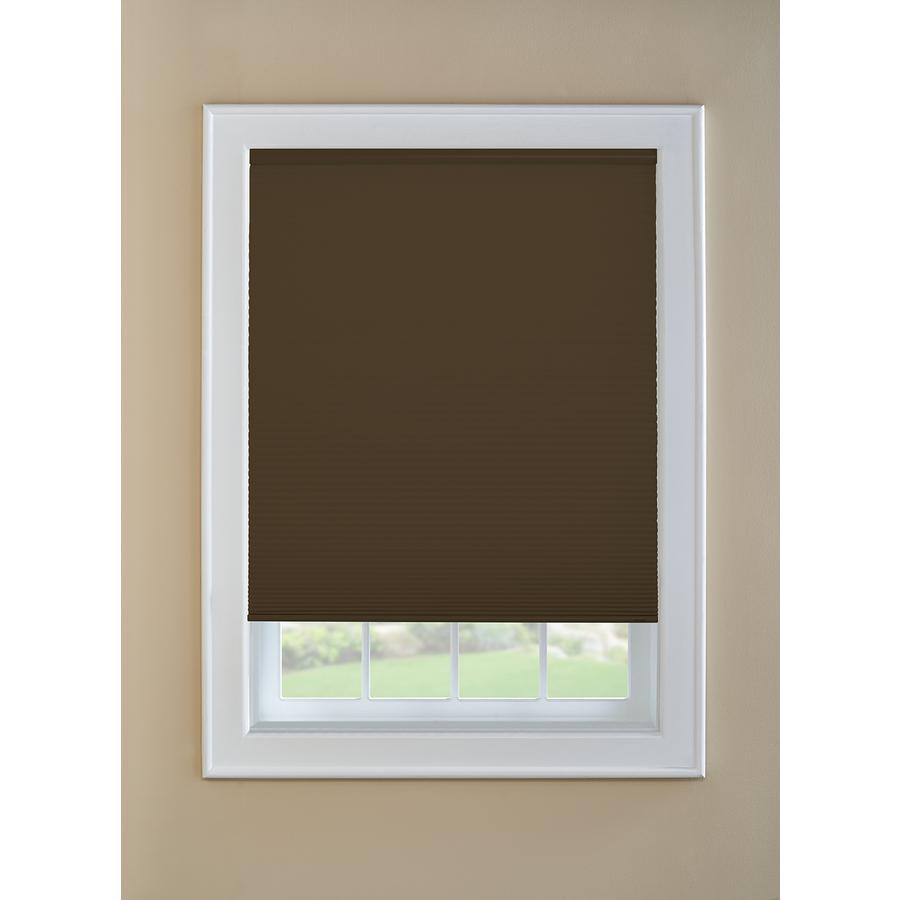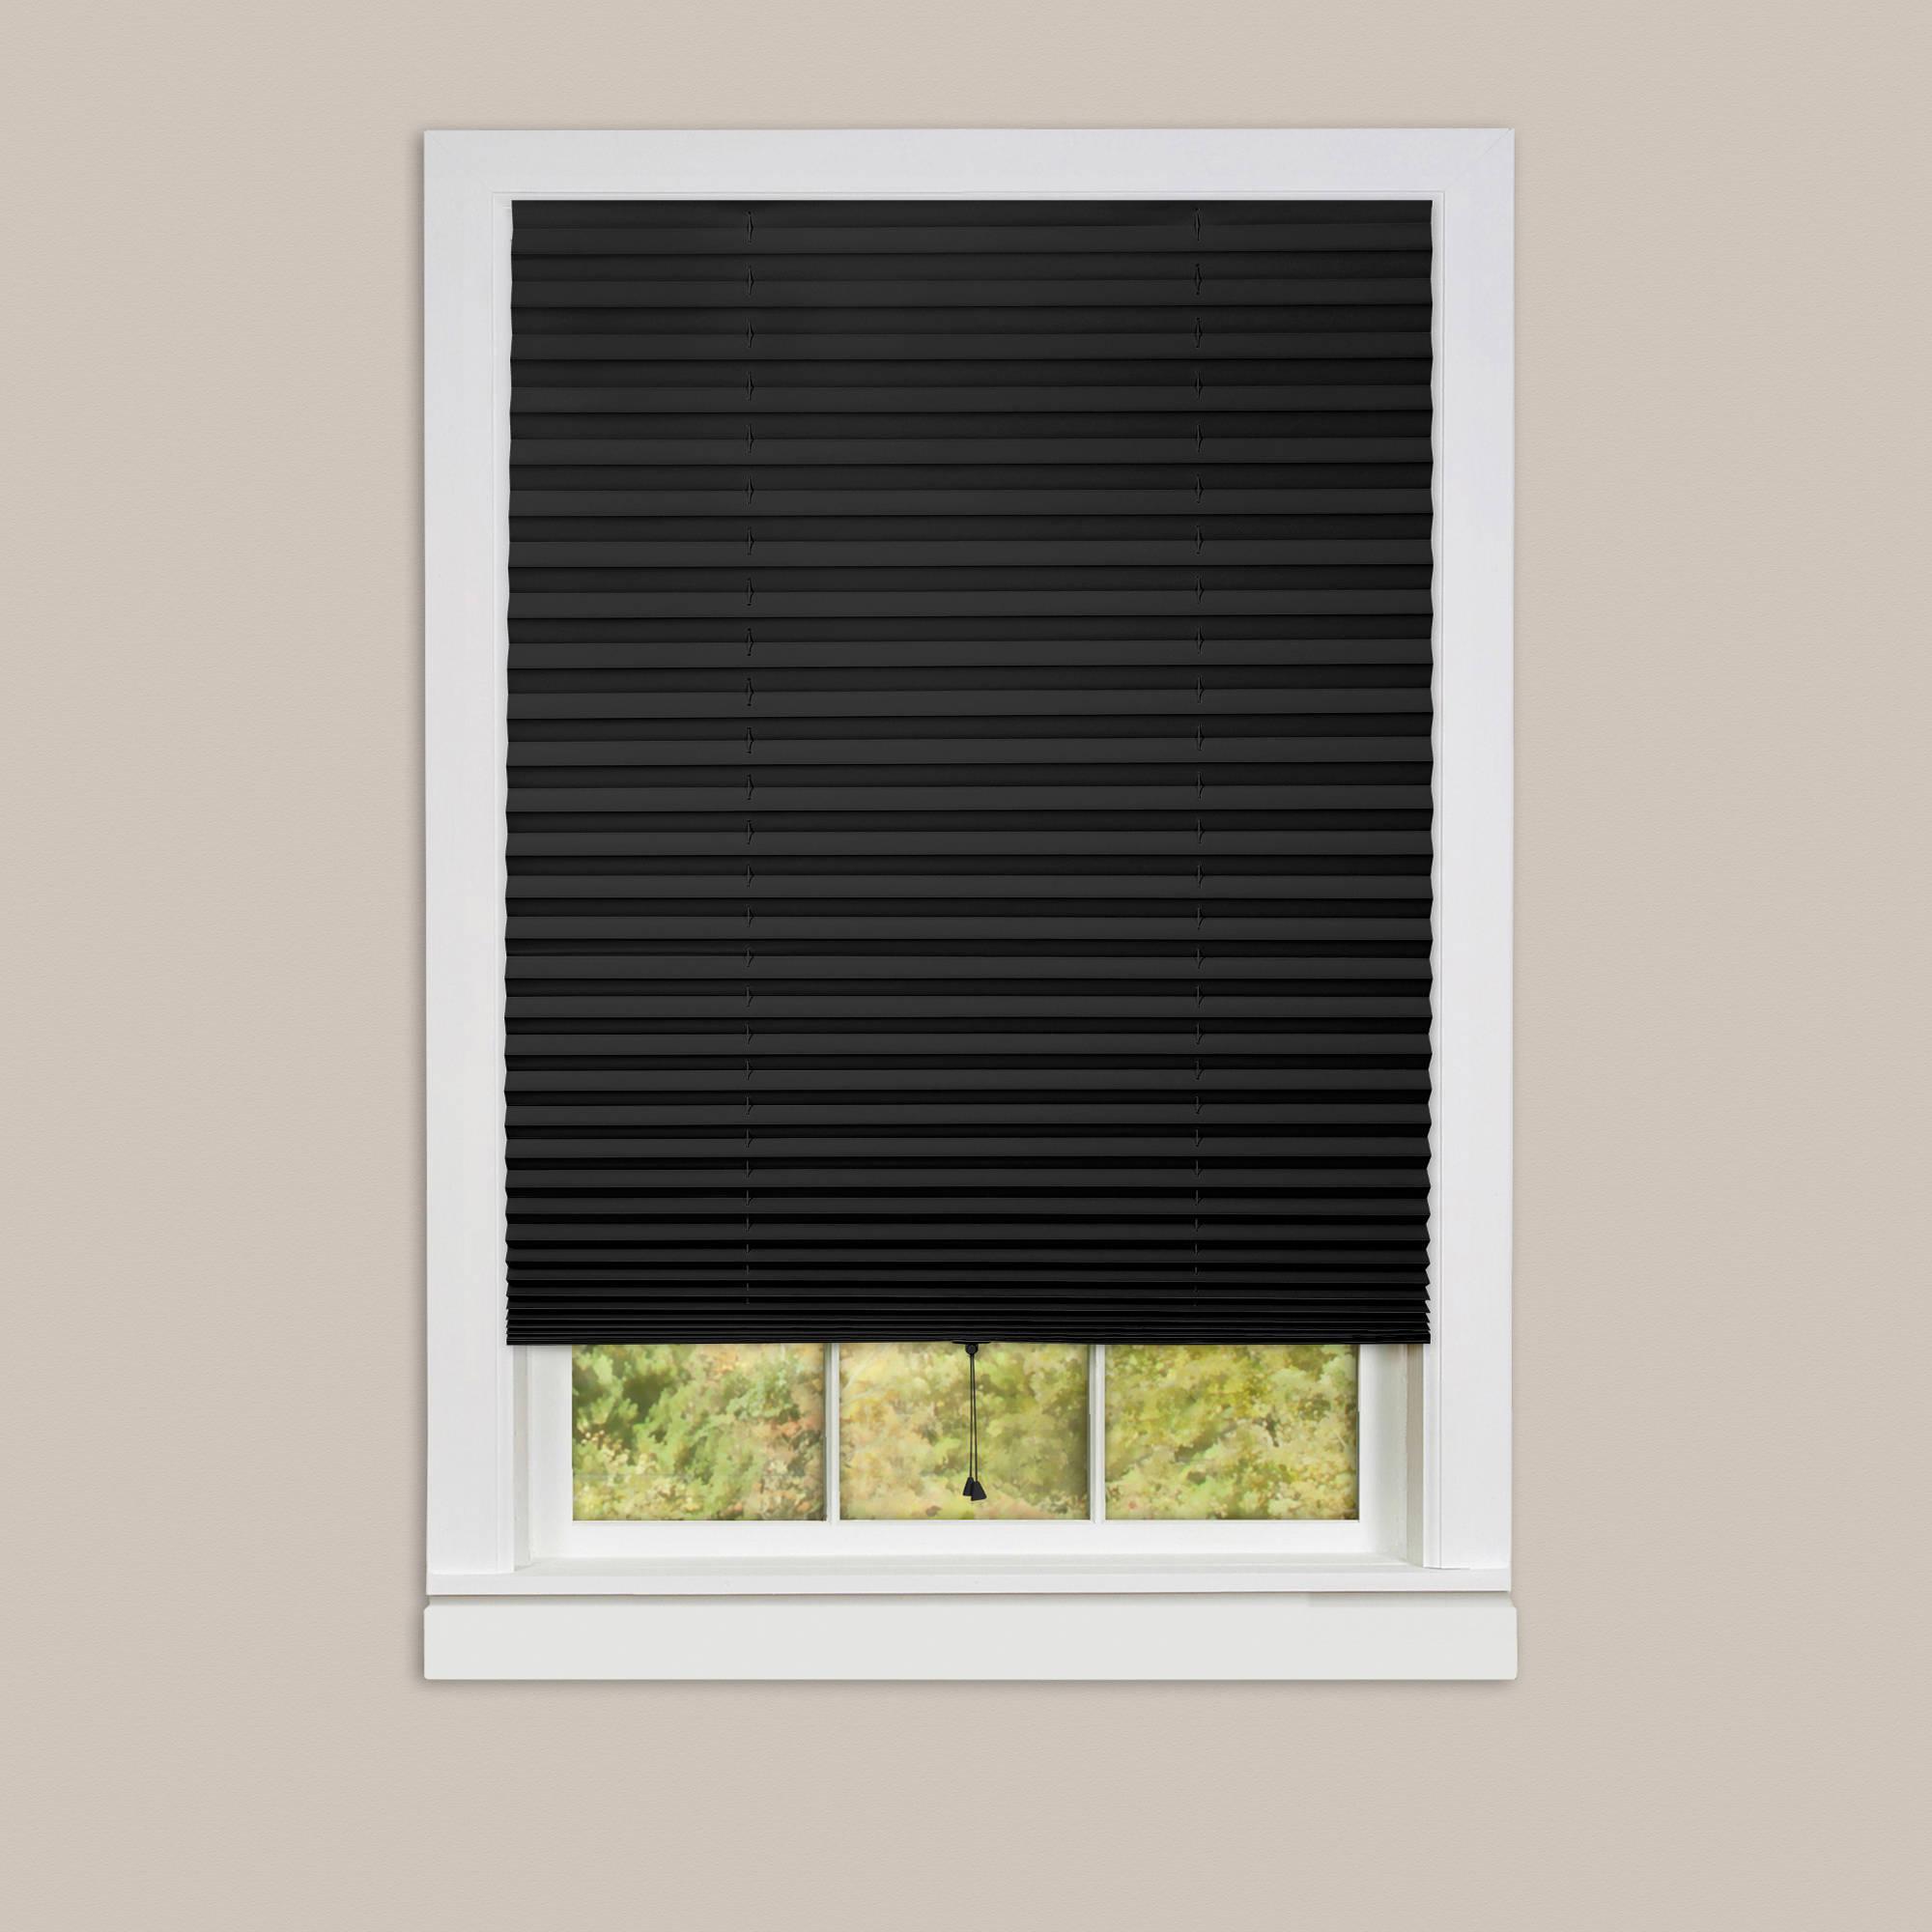The first image is the image on the left, the second image is the image on the right. Given the left and right images, does the statement "There are shaded windows near the sofas." hold true? Answer yes or no. No. The first image is the image on the left, the second image is the image on the right. For the images displayed, is the sentence "The left image includes at least two white-framed rectangular windows with colored shades and no drapes, behind beige furniture piled with pillows." factually correct? Answer yes or no. No. 